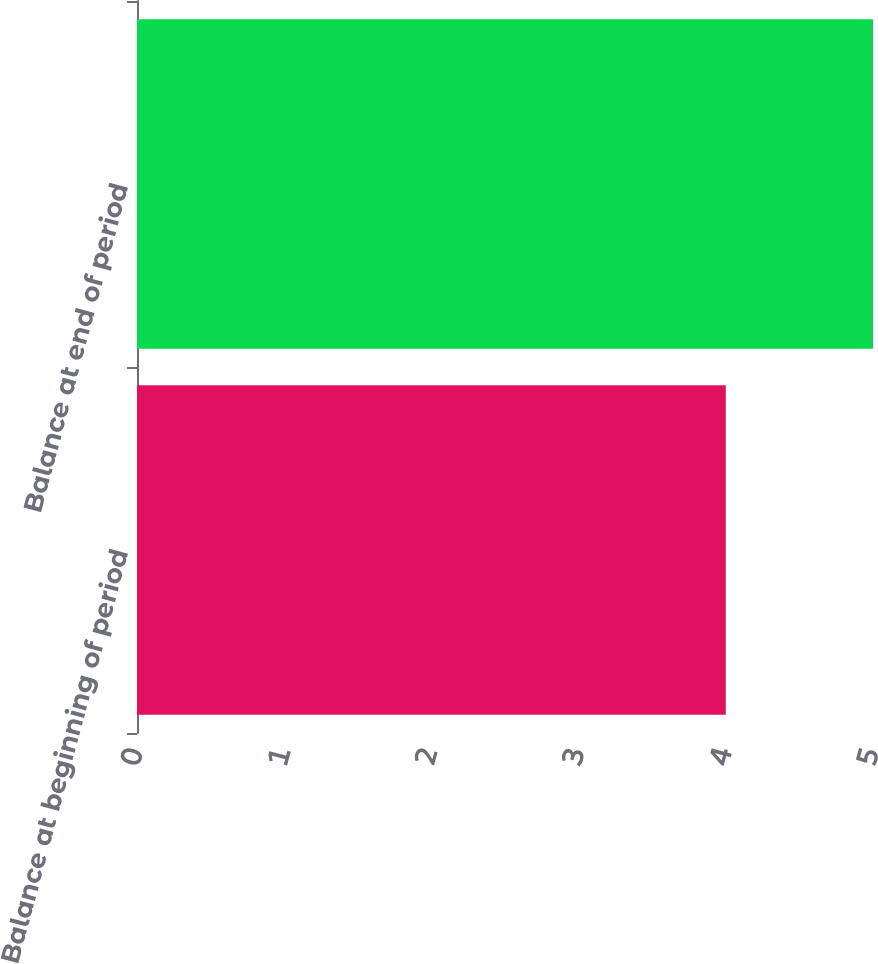<chart> <loc_0><loc_0><loc_500><loc_500><bar_chart><fcel>Balance at beginning of period<fcel>Balance at end of period<nl><fcel>4<fcel>5<nl></chart> 